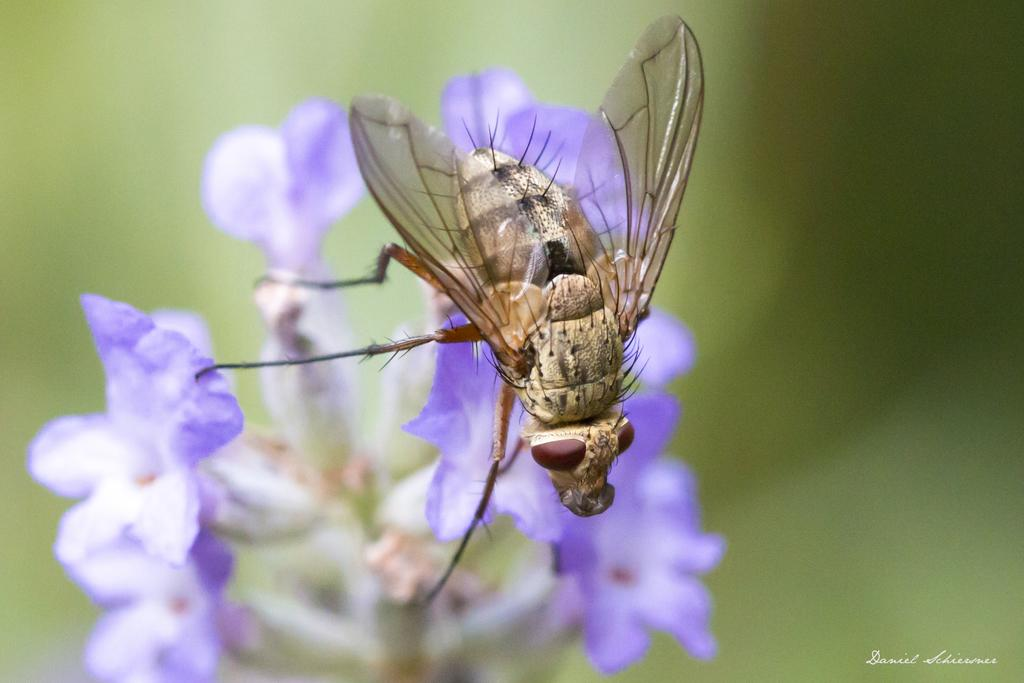What type of creature can be seen in the image? There is an insect in the image. Where is the insect located in the image? The insect is sitting on a flower. What is the main subject in the center of the image? There are flowers in the center of the image. How would you describe the background of the image? The background of the image is blurry. What type of knife is being used to apply paste to the donkey in the image? There is no donkey, knife, or paste present in the image. 